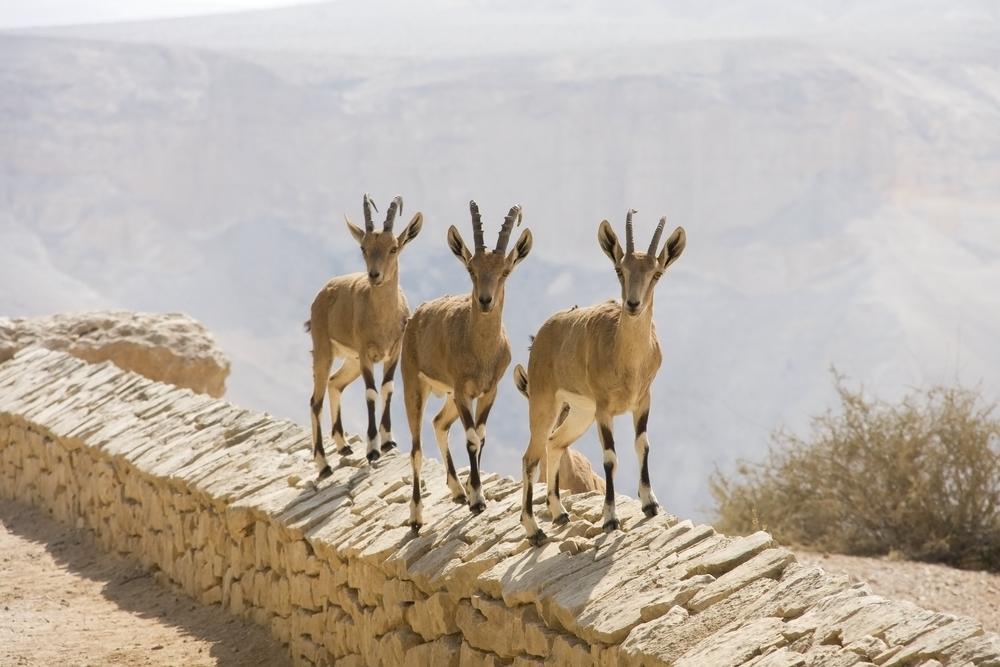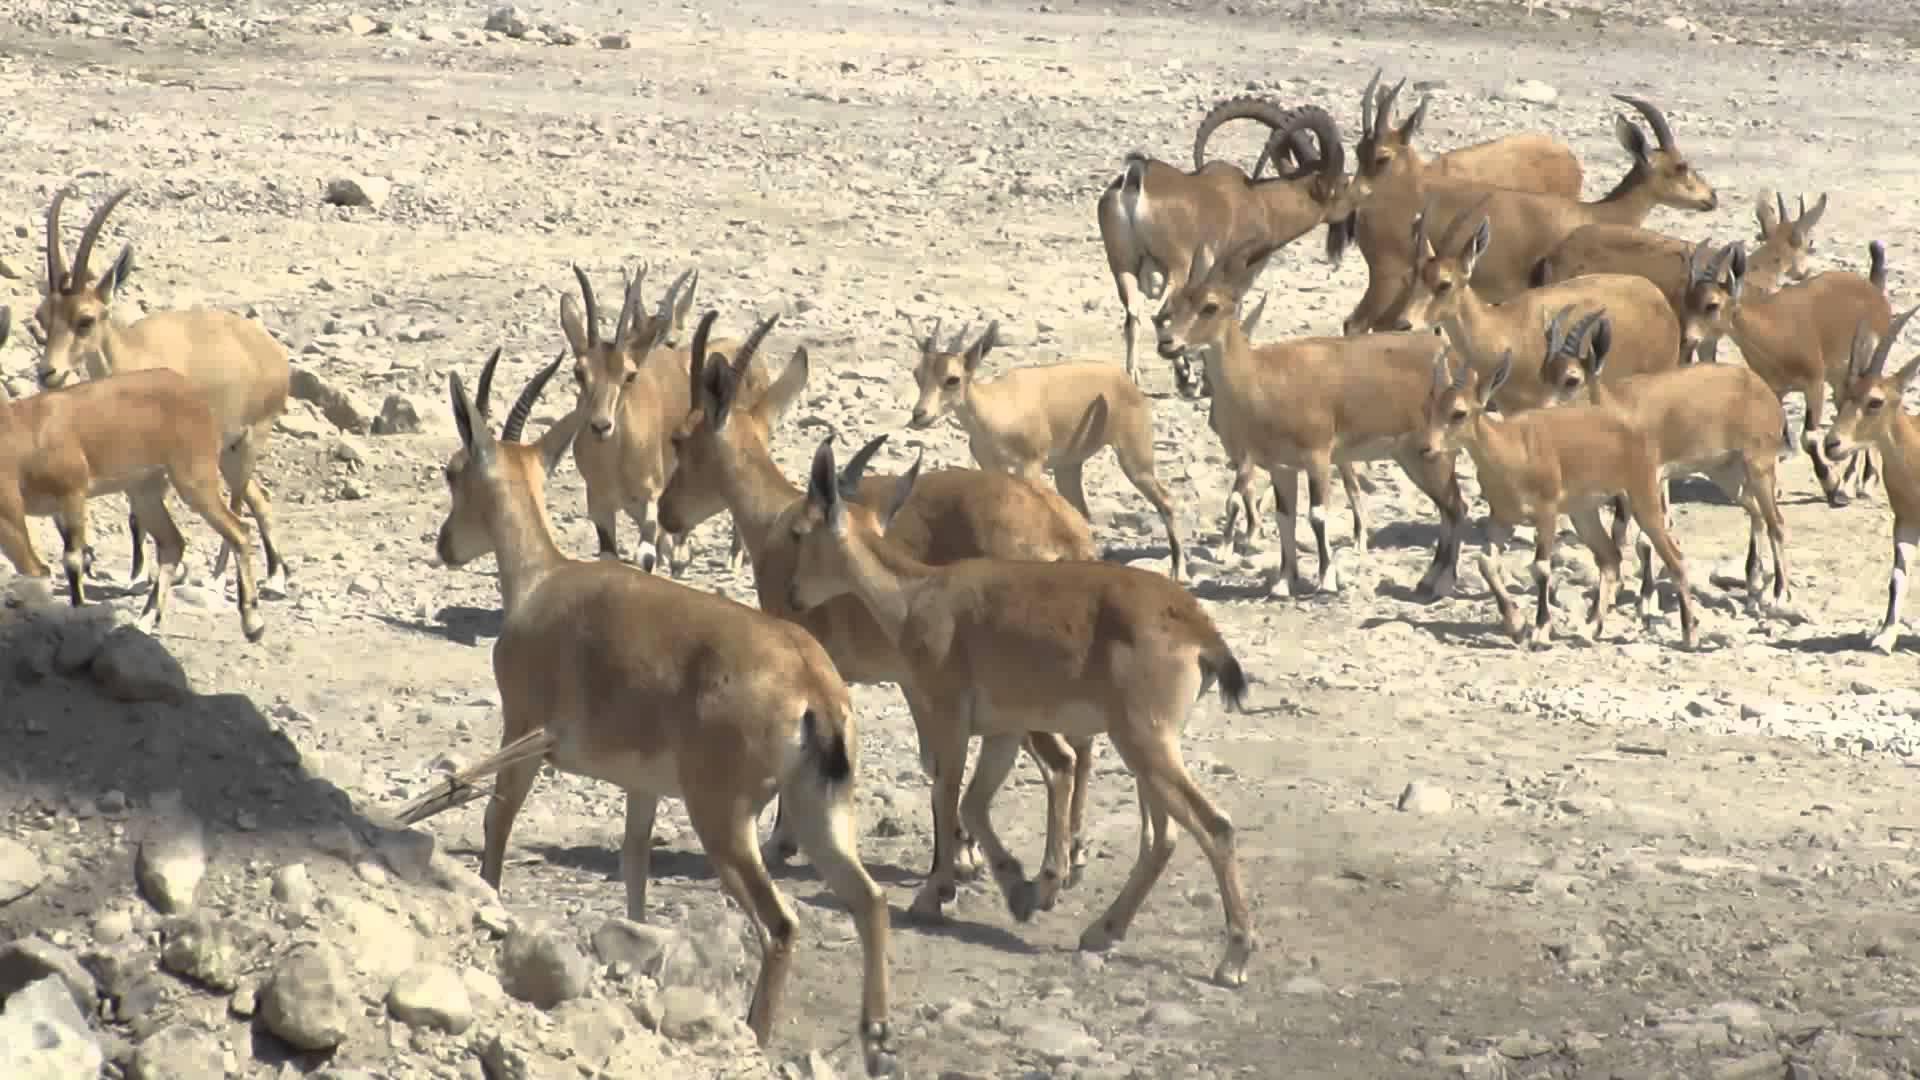The first image is the image on the left, the second image is the image on the right. Considering the images on both sides, is "An image shows three horned animals on a surface with flat stones arranged in a row." valid? Answer yes or no. Yes. The first image is the image on the left, the second image is the image on the right. Given the left and right images, does the statement "At least one of the animals is standing in a grassy area." hold true? Answer yes or no. No. 